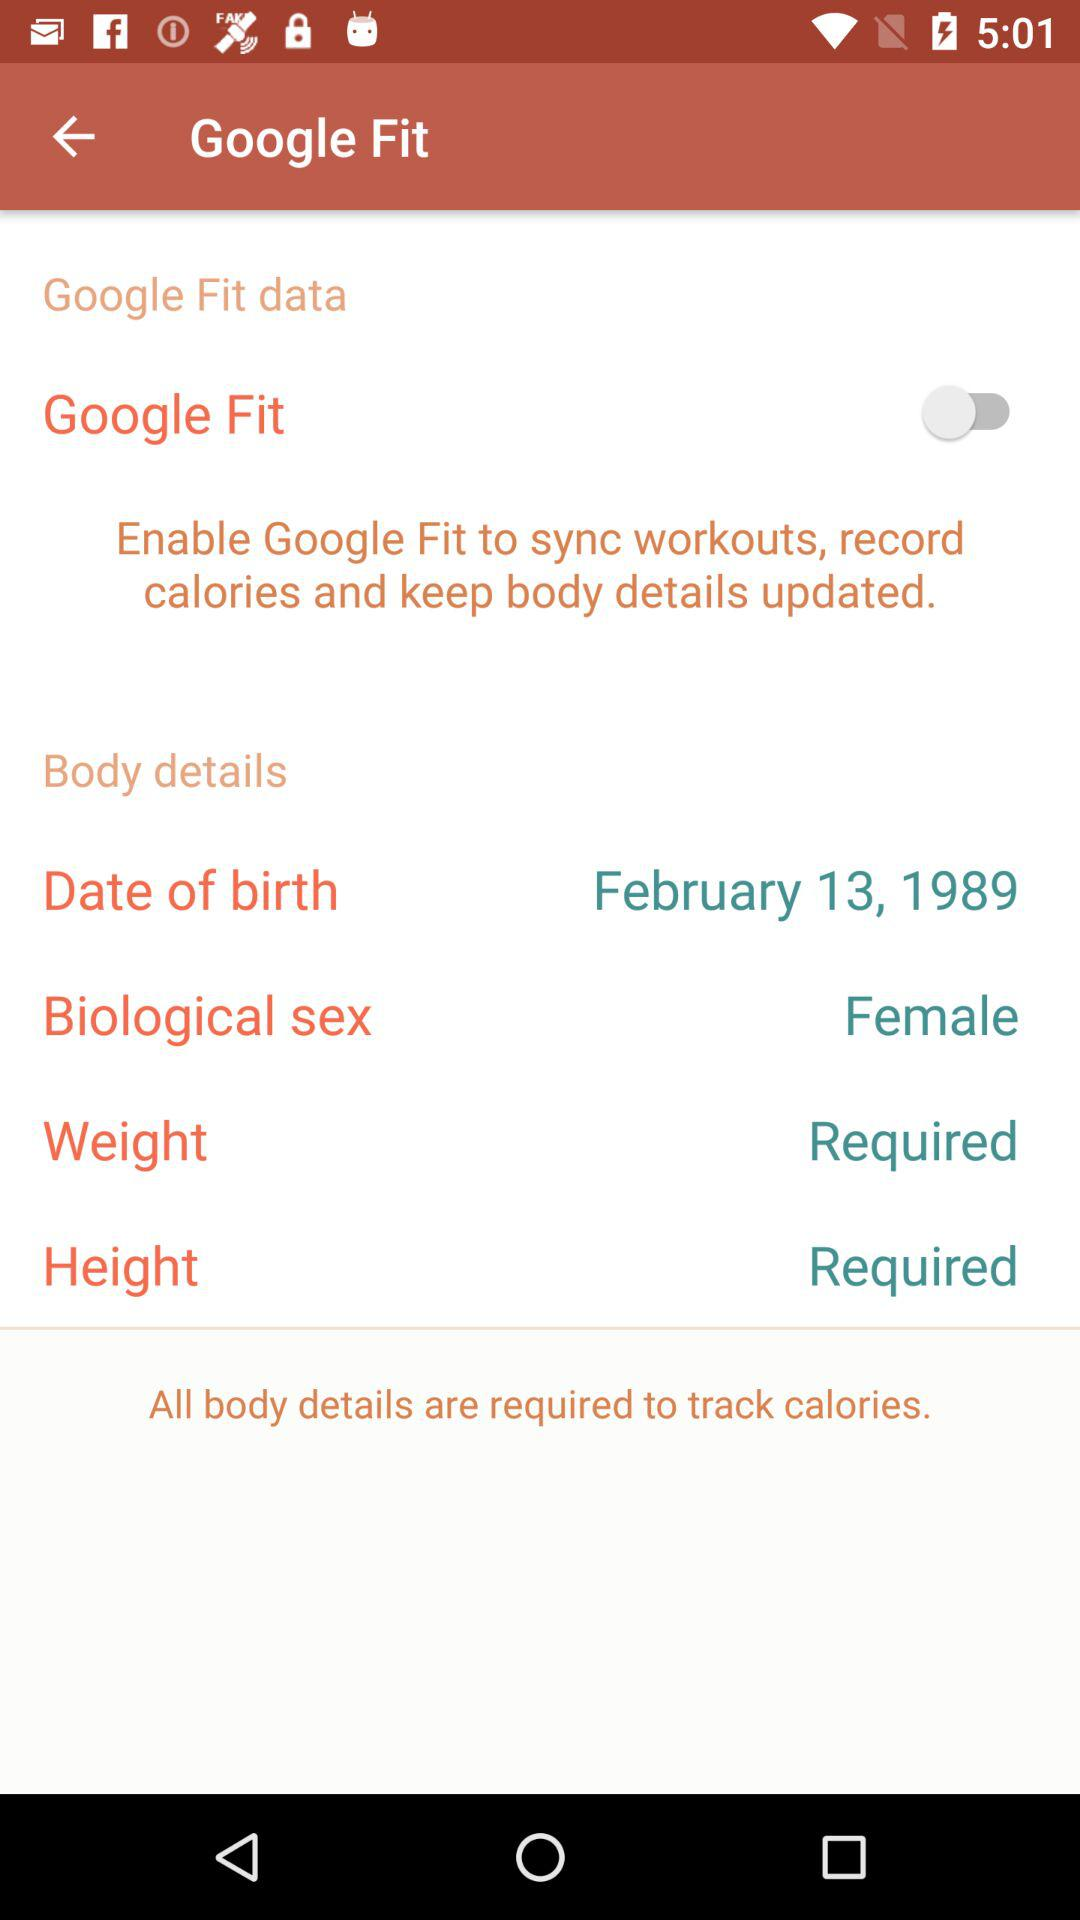How tall is the user?
When the provided information is insufficient, respond with <no answer>. <no answer> 